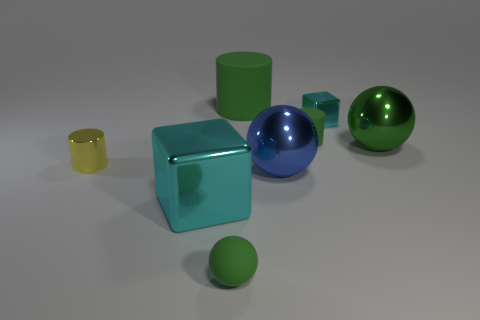Add 2 green rubber objects. How many green rubber objects exist? 5 Add 2 tiny cyan shiny things. How many objects exist? 10 Subtract all yellow cylinders. How many cylinders are left? 2 Subtract all green rubber cylinders. How many cylinders are left? 1 Subtract 0 yellow cubes. How many objects are left? 8 Subtract all blocks. How many objects are left? 6 Subtract all blue blocks. Subtract all yellow spheres. How many blocks are left? 2 Subtract all gray cubes. How many green balls are left? 2 Subtract all big metallic things. Subtract all small yellow cylinders. How many objects are left? 4 Add 2 big things. How many big things are left? 6 